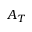<formula> <loc_0><loc_0><loc_500><loc_500>A _ { T }</formula> 